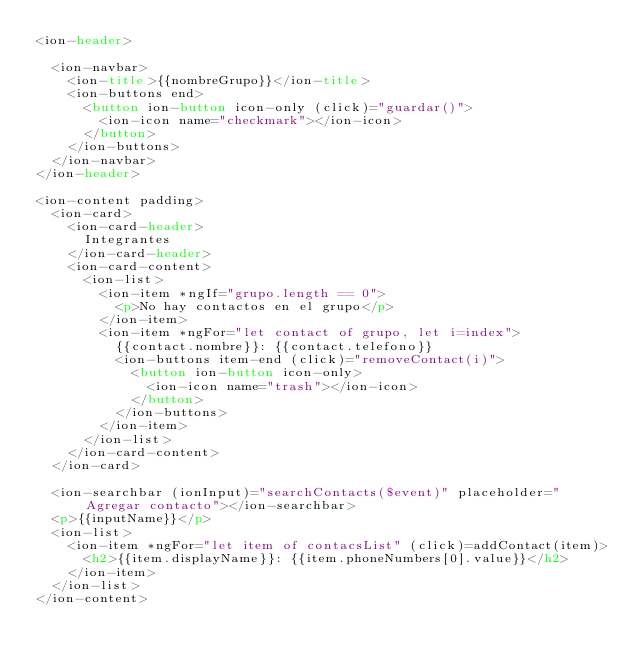<code> <loc_0><loc_0><loc_500><loc_500><_HTML_><ion-header>

  <ion-navbar>
    <ion-title>{{nombreGrupo}}</ion-title>
    <ion-buttons end>
      <button ion-button icon-only (click)="guardar()">
        <ion-icon name="checkmark"></ion-icon>
      </button>
    </ion-buttons>
  </ion-navbar>
</ion-header>

<ion-content padding>
  <ion-card>
    <ion-card-header>
      Integrantes
    </ion-card-header>
    <ion-card-content>
      <ion-list>
        <ion-item *ngIf="grupo.length == 0">
          <p>No hay contactos en el grupo</p>
        </ion-item>
        <ion-item *ngFor="let contact of grupo, let i=index">
          {{contact.nombre}}: {{contact.telefono}}
          <ion-buttons item-end (click)="removeContact(i)">
            <button ion-button icon-only>
              <ion-icon name="trash"></ion-icon>
            </button>
          </ion-buttons>
        </ion-item>
      </ion-list>
    </ion-card-content>
  </ion-card>

  <ion-searchbar (ionInput)="searchContacts($event)" placeholder="Agregar contacto"></ion-searchbar>
  <p>{{inputName}}</p>
  <ion-list>
    <ion-item *ngFor="let item of contacsList" (click)=addContact(item)>
      <h2>{{item.displayName}}: {{item.phoneNumbers[0].value}}</h2>
    </ion-item>
  </ion-list>
</ion-content>
</code> 